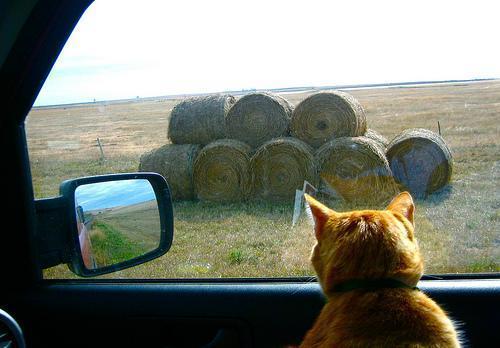How many cats are there?
Give a very brief answer. 1. 